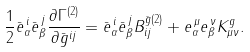<formula> <loc_0><loc_0><loc_500><loc_500>\frac { 1 } { 2 } { \bar { e } } _ { \alpha } ^ { \, i } { \bar { e } } _ { \beta } ^ { \, j } \frac { \partial \Gamma ^ { ( 2 ) } } { \partial \bar { g } ^ { i j } } = { \bar { e } } _ { \alpha } ^ { \, i } { \bar { e } } _ { \beta } ^ { \, j } B _ { i j } ^ { \bar { g } ( 2 ) } + e _ { \alpha } ^ { \, \mu } e _ { \beta } ^ { \, \nu } K ^ { g } _ { \mu \nu } .</formula> 